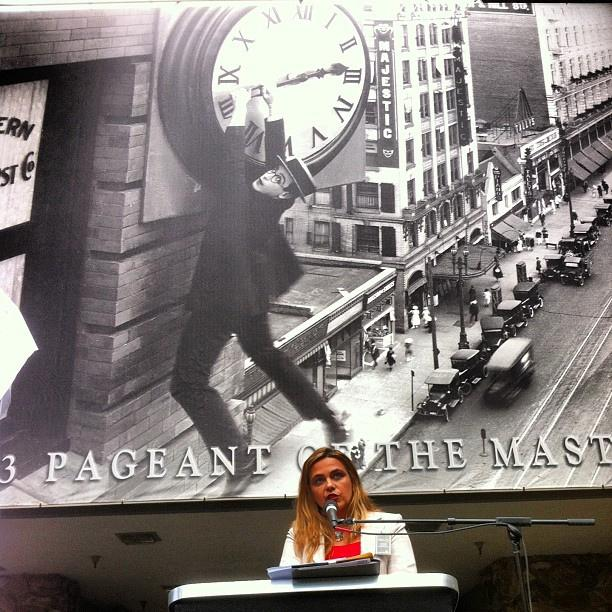What is this movie most likely to be?

Choices:
A) horror
B) comedy
C) action
D) history comedy 